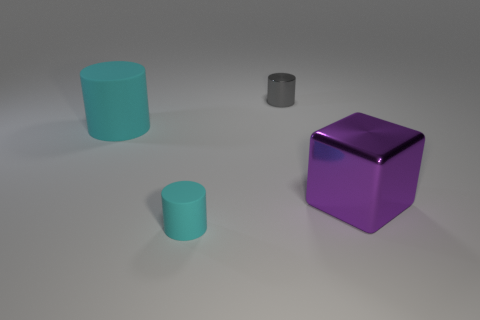There is a small object in front of the big matte cylinder; does it have the same color as the cube?
Your answer should be very brief. No. How many cyan things are large cylinders or cylinders?
Your response must be concise. 2. How many other things are the same shape as the large shiny thing?
Ensure brevity in your answer.  0. Are the small gray object and the large cylinder made of the same material?
Make the answer very short. No. What material is the cylinder that is both behind the purple cube and in front of the tiny metal cylinder?
Your answer should be compact. Rubber. There is a shiny thing that is left of the cube; what color is it?
Provide a short and direct response. Gray. Are there more gray cylinders that are in front of the large cylinder than things?
Provide a short and direct response. No. How many other things are there of the same size as the cube?
Make the answer very short. 1. There is a big metal block; how many purple metal cubes are left of it?
Offer a very short reply. 0. Are there the same number of large cyan objects that are right of the small gray metallic cylinder and purple things that are on the left side of the cube?
Provide a succinct answer. Yes. 